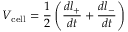Convert formula to latex. <formula><loc_0><loc_0><loc_500><loc_500>V _ { c e l l } = \frac { 1 } { 2 } \left ( \frac { d l _ { + } } { d t } + \frac { d l _ { - } } { d t } \right )</formula> 